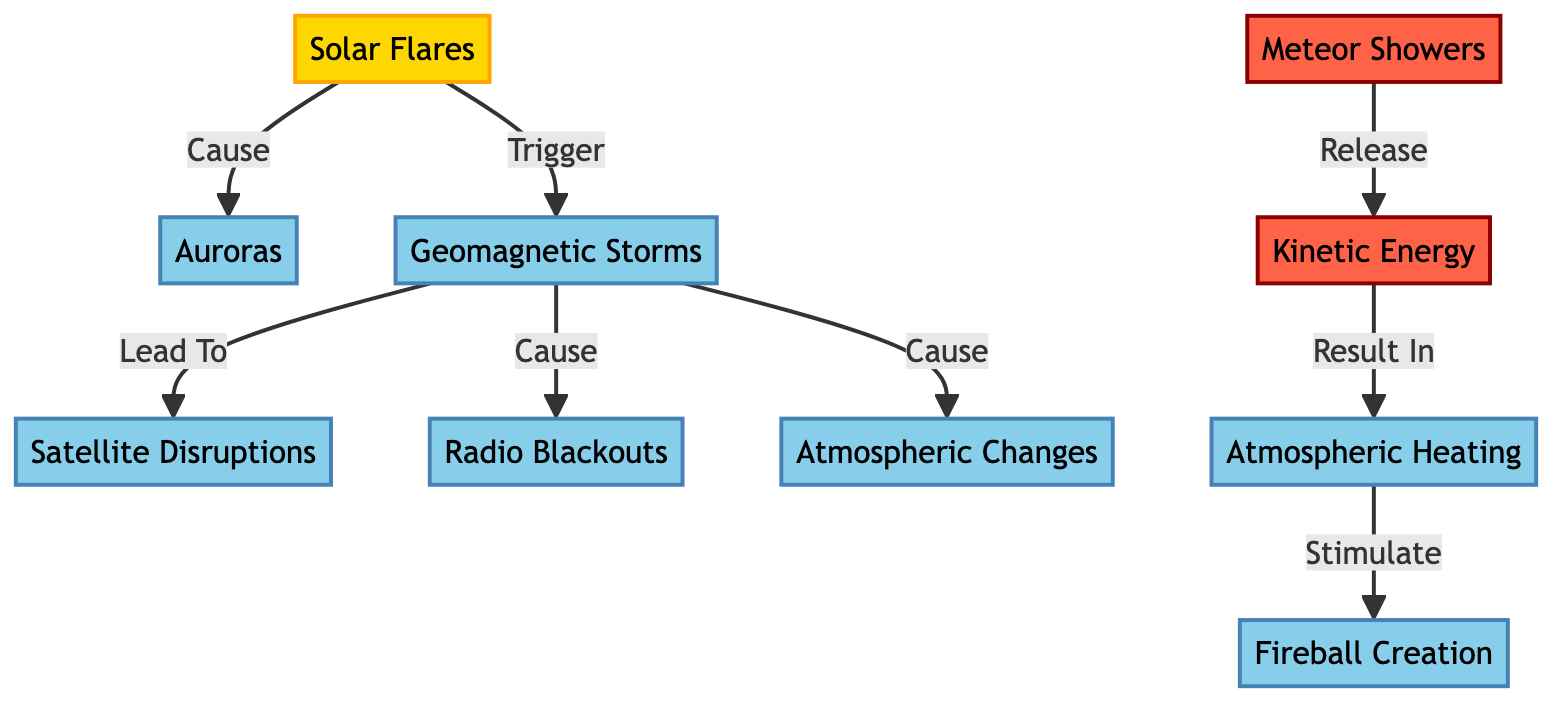What are the main effects of solar flares on Earth's atmosphere? The diagram shows that solar flares cause auroras, trigger geomagnetic storms, and lead to a variety of atmospheric effects such as satellite disruptions, radio blackouts, and atmospheric changes.
Answer: Auroras, Geomagnetic Storms How many atmospheric effects are shown in the diagram? In the diagram, there are five nodes classified as atmospheric effects: Auroras, Geomagnetic Storms, Satellite Disruptions, Radio Blackouts, and Atmospheric Changes.
Answer: Five What leads to the creation of fireballs? The diagram indicates that atmospheric heating, which results from kinetic energy released by meteor showers, stimulates fireball creation. Following the flow, it starts with meteor showers releasing kinetic energy, which then contributes to atmospheric heating.
Answer: Atmospheric Heating Which event triggers satellite disruptions according to the diagram? Geomagnetic storms are shown in the diagram as the event that leads to satellite disruptions. The flow explicitly connects geomagnetic storms to this atmospheric effect.
Answer: Geomagnetic Storms What is the relationship between meteor showers and atmospheric heating? Meteor showers release kinetic energy, and this kinetic energy results in atmospheric heating as shown in the diagram. The relationship is direct and sequential, reflecting a cause (meteor showers) and effect (atmospheric heating).
Answer: Kinetic Energy 